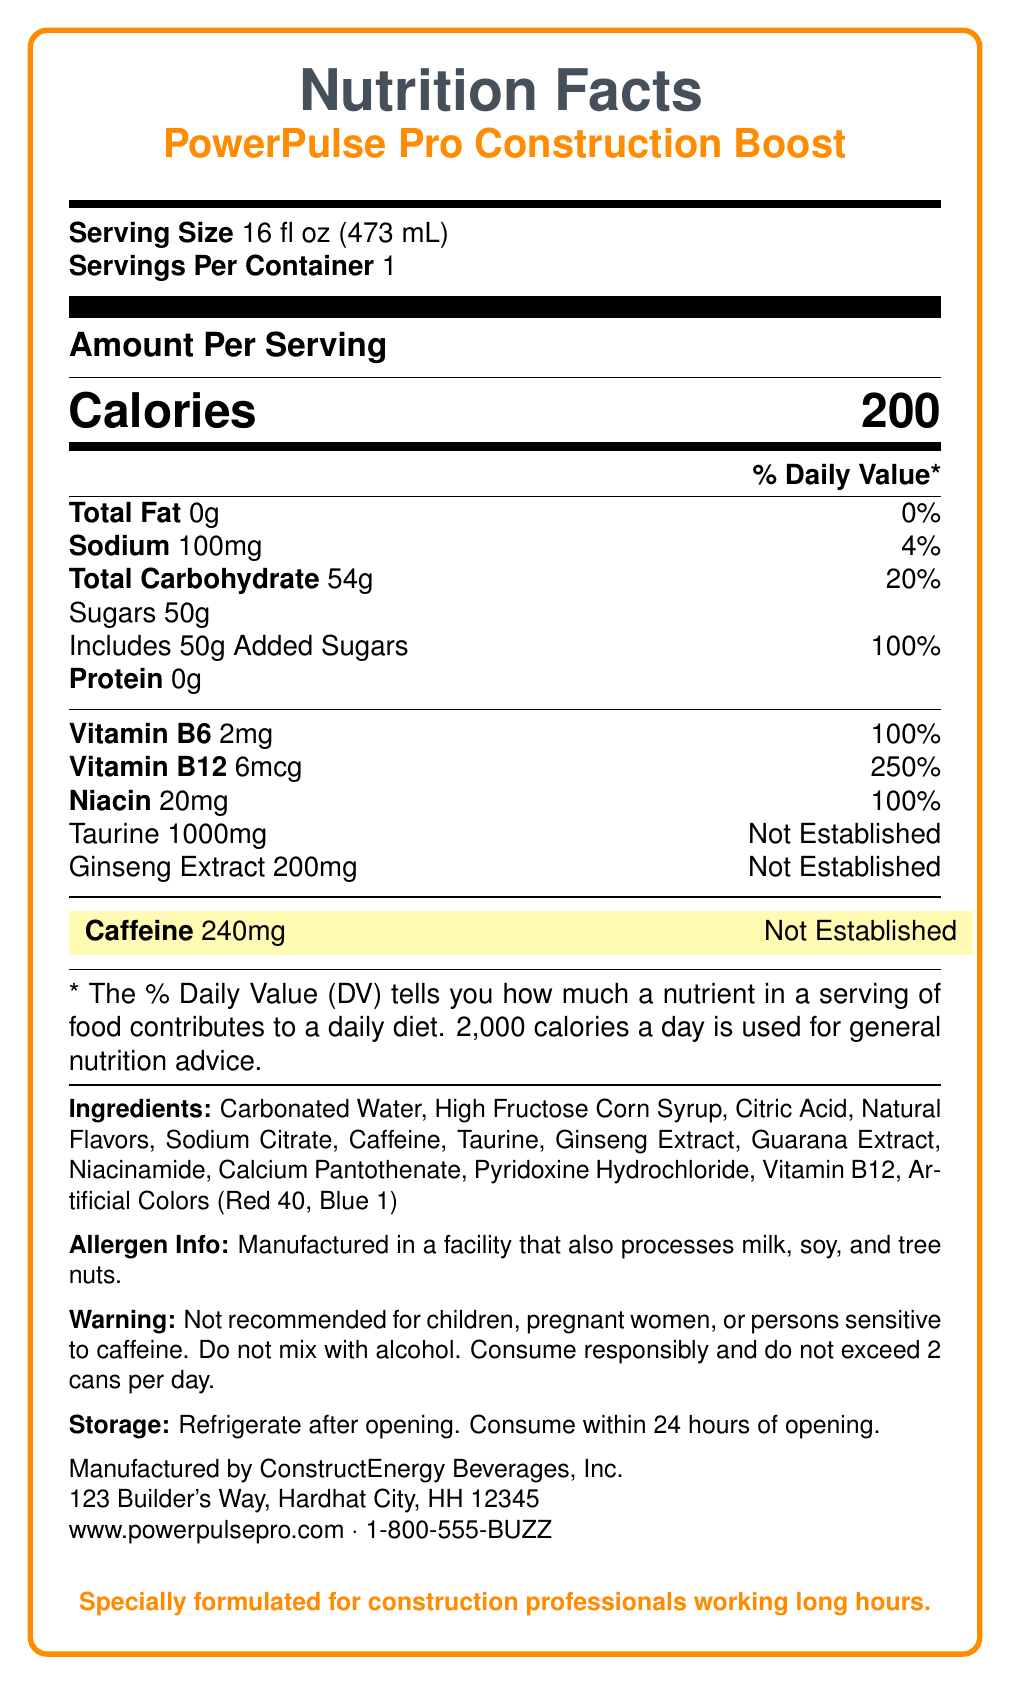**Short-answer:**
How many calories are in one serving of PowerPulse Pro Construction Boost? The document states "Calories 200" under the section "Amount Per Serving".
Answer: 200 What is the serving size of the PowerPulse Pro Construction Boost? The document lists the serving size as "16 fl oz (473 mL)" at the top.
Answer: 16 fl oz (473 mL) What is the total amount of sugars in one serving? The section on carbohydrates lists the total sugars as "50g" including "50g Added Sugars".
Answer: 50g What is the sodium content in one serving? The document specifies "Sodium 100mg" with a daily value percentage of 4%.
Answer: 100mg What is the amount of Vitamin B12 in one serving? The document states that Vitamin B12 is "6mcg" with a daily value percentage of 250%.
Answer: 6mcg **Multiple-choice:**
How much caffeine is contained in one serving?  
A. 100mg  
B. 150mg  
C. 200mg  
D. 240mg The document highlights the caffeine content as "240mg".
Answer: D Which of the following is listed as an ingredient in PowerPulse Pro Construction Boost?  
I. Guarana Extract  
II. Apple Juice  
III. Sodium Citrate  
IV. Green Tea Extract  
A. I and II  
B. II and IV  
C. I and III  
D. III and IV The ingredients listed include Guarana Extract and Sodium Citrate but do not include Apple Juice or Green Tea Extract.
Answer: C **Yes/No (True/False):**
Is the daily value percentage for taurine established? The document notes that the daily value percentage for taurine is "Not Established".
Answer: No **Summary:**
Summarize the main idea of the Nutrition Facts Label for PowerPulse Pro Construction Boost. The document provides detailed information regarding the nutritional content and other related info such as ingredients and usage warnings, making it useful for consumers.
Answer: The Nutrition Facts Label details the nutritional content of one 16 fl oz serving of PowerPulse Pro Construction Boost. It provides various specifics such as calories (200), total fat (0g), sodium (100mg), total carbohydrates (54g), total sugars (50g), protein (0g), as well as amounts of vitamins (B6 and B12) and minerals. Caffeine (240mg) is highlighted, among other ingredients like taurine and ginseng extract. The label also contains additional information such as the ingredients list, allergen info, storage instructions, and a warning recommending responsible consumption. **Unanswerable:**
What is the price of one can of PowerPulse Pro Construction Boost? The document does not provide any details about the price of the product.
Answer: Not enough information 